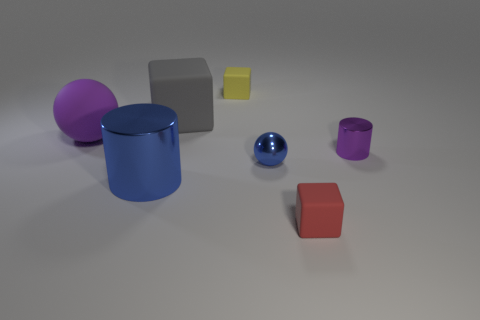There is a big metallic object that is the same color as the metallic sphere; what is its shape?
Ensure brevity in your answer.  Cylinder. What number of red rubber things have the same size as the yellow cube?
Provide a short and direct response. 1. Are there fewer yellow rubber cubes that are left of the large purple object than matte cylinders?
Your response must be concise. No. What number of blue metallic objects are on the right side of the red rubber thing?
Your response must be concise. 0. What is the size of the rubber object in front of the cylinder that is on the right side of the tiny object on the left side of the metallic sphere?
Your answer should be compact. Small. Is the shape of the tiny purple metallic object the same as the big matte object to the left of the big gray matte block?
Offer a terse response. No. What size is the blue cylinder that is the same material as the tiny ball?
Make the answer very short. Large. Is there anything else that has the same color as the small shiny cylinder?
Offer a very short reply. Yes. What is the material of the purple thing behind the cylinder that is on the right side of the matte object in front of the small blue metal sphere?
Provide a succinct answer. Rubber. How many matte things are purple cylinders or purple spheres?
Offer a terse response. 1. 